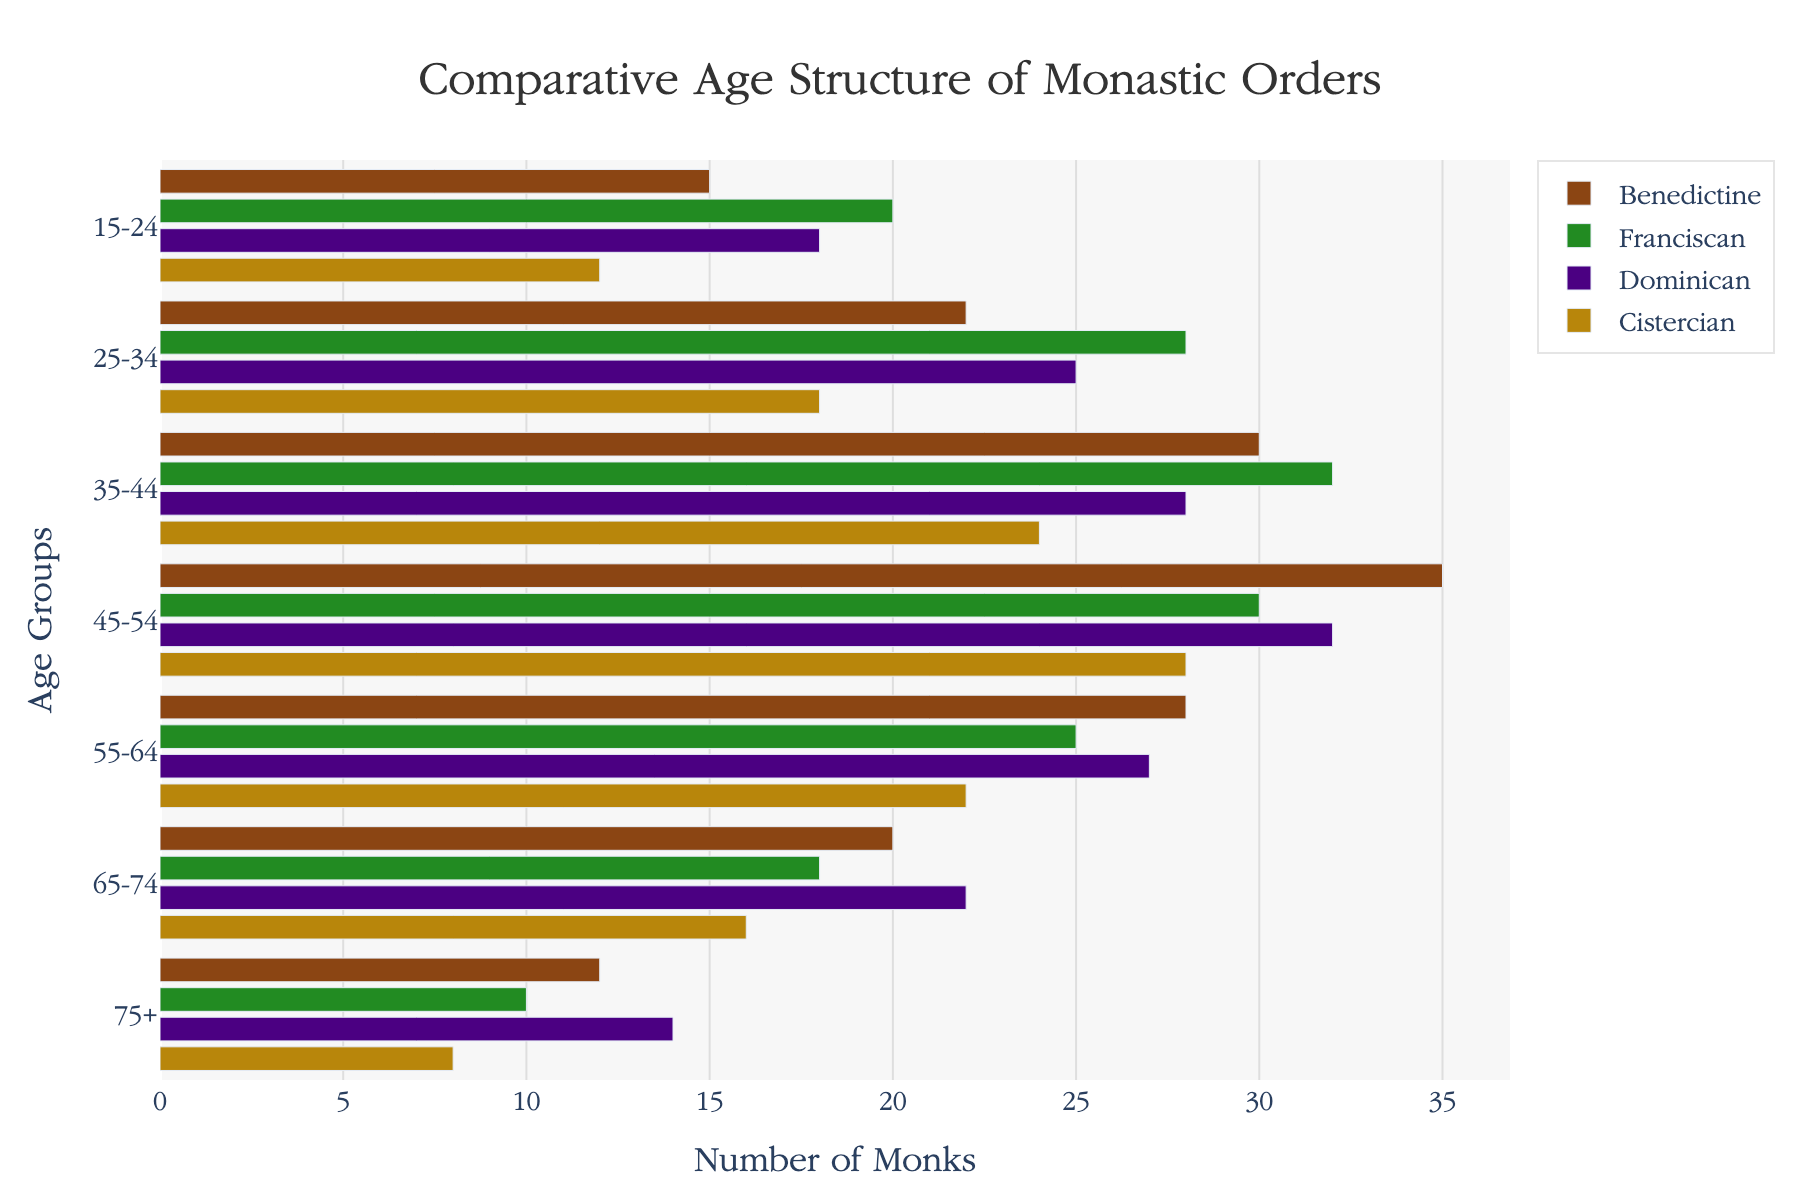what is the title of the figure? The title is displayed prominently at the top center of the figure which helps in understanding the overall content.
Answer: Comparative Age Structure of Monastic Orders Which age group has the highest number of monks in the Benedictine order? Refer to the horizontal bar corresponding to the Benedictine order and identify the longest bar.
Answer: 45-54 How many monks are there in the 65-74 age group across all orders? Sum the values for the 65-74 age group in each order. Benedictine: 20, Franciscan: 18, Dominican: 22, Cistercian: 16. Total: 20 + 18 + 22 + 16.
Answer: 76 Which monastic order has the smallest number of monks in the 75+ age group? Compare the length of the horizontal bars in the 75+ age group for all orders and identify the shortest one.
Answer: Cistercian What is the difference in the number of monks between age groups 35-44 and 55-64 for the Franciscan order? Subtract the number of monks in the 55-64 age group from the number in the 35-44 age group for the Franciscan order. 35-44: 32, 55-64: 25, so 32 - 25.
Answer: 7 Which age group has the most balanced distribution of monks across all four orders? Compare the length of bars for each age group. The most balanced group will have bars that are similar in length.
Answer: 35-44 How many more monks are there in the 25-34 age group in the Dominican order compared to the Cistercian order? Subtract the number of monks in the 25-34 age group in the Cistercian order from the number in the Dominican order. 25-34: 25 (Dominican), 18 (Cistercian), so 25 - 18.
Answer: 7 Which monastic order has the highest number of monks overall? Sum the number of monks in each age group for each monastic order, then compare the sums. Benedictine: 162, Franciscan: 163, Dominican: 166, Cistercian: 128.
Answer: Dominican 